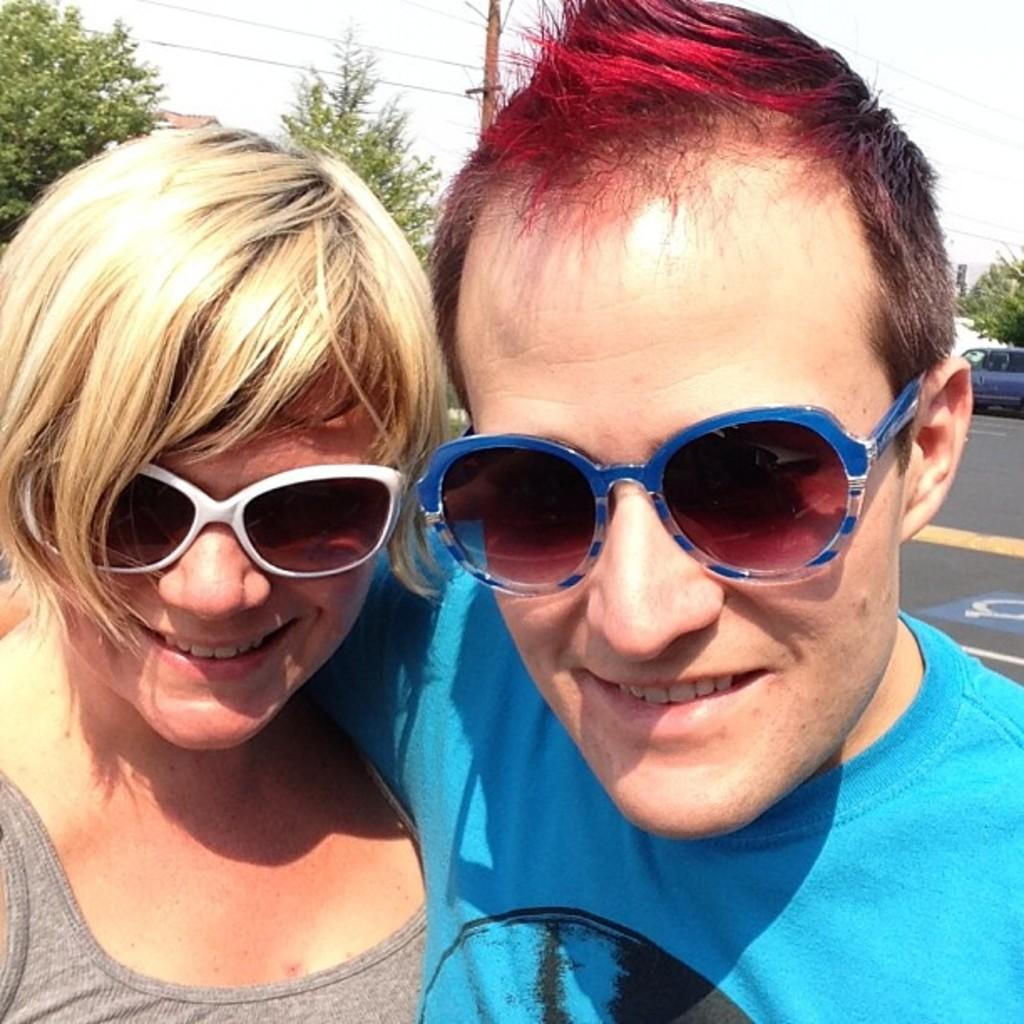How many people are in the image? There are two persons standing in the image. What is the facial expression of the persons? The persons are smiling. What type of vegetation is visible behind the persons? There are trees behind the persons. What other objects can be seen in the background? There are poles and vehicles in the background. What is visible at the top of the image? The sky is visible at the top of the image. What type of humor is being shared between the persons in the image? There is no indication of humor being shared between the persons in the image; they are simply smiling. Is there a meeting taking place in the image? There is no indication of a meeting in the image; it simply shows two persons standing and smiling. 